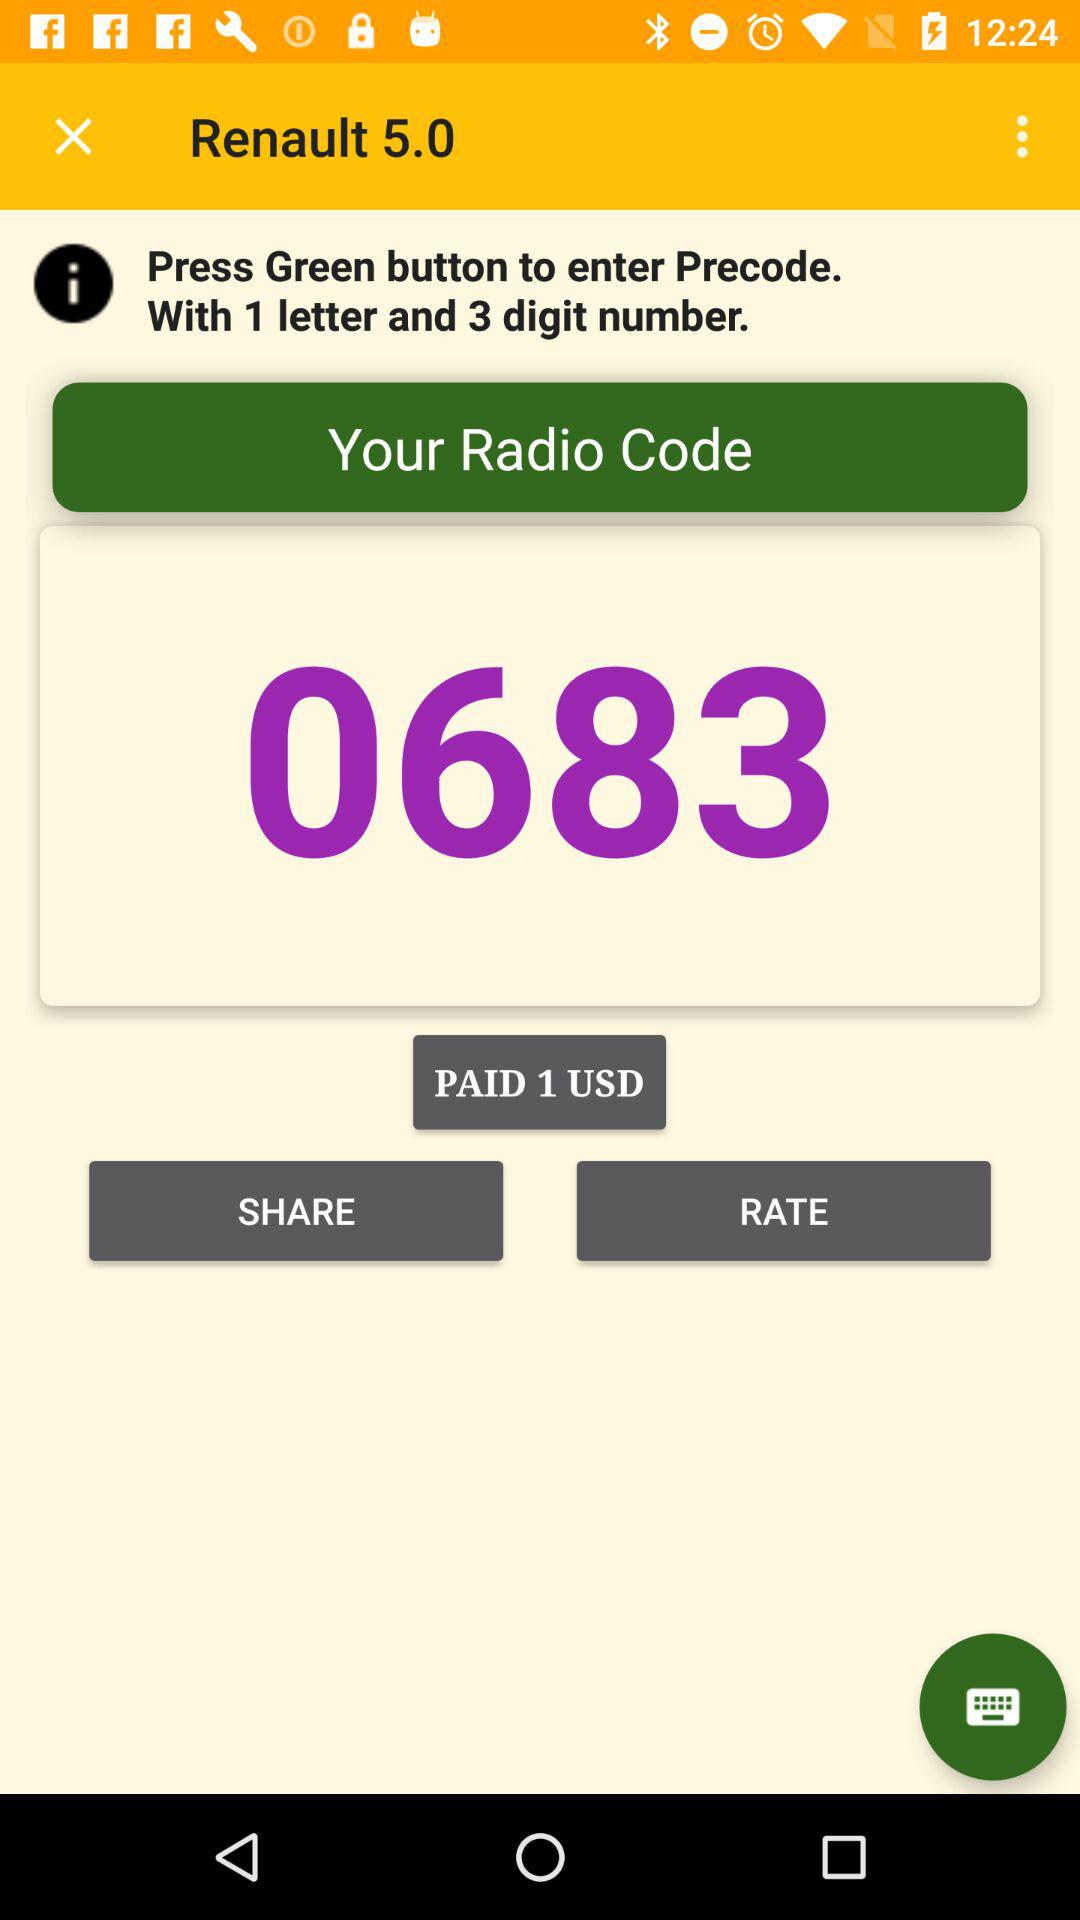Which button should be pressed to enter the Precode? To enter the Precode, the "Green" button should be pressed. 